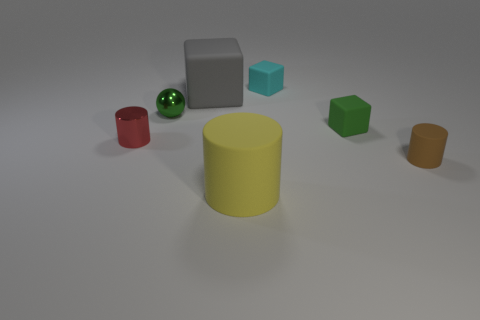Add 2 tiny green blocks. How many objects exist? 9 Subtract all cyan cubes. How many cubes are left? 2 Subtract all yellow cylinders. How many cylinders are left? 2 Subtract 1 cylinders. How many cylinders are left? 2 Subtract all balls. How many objects are left? 6 Subtract all cyan spheres. How many gray blocks are left? 1 Subtract all tiny cyan metallic cylinders. Subtract all cyan things. How many objects are left? 6 Add 4 tiny cyan blocks. How many tiny cyan blocks are left? 5 Add 6 small brown cylinders. How many small brown cylinders exist? 7 Subtract 0 brown blocks. How many objects are left? 7 